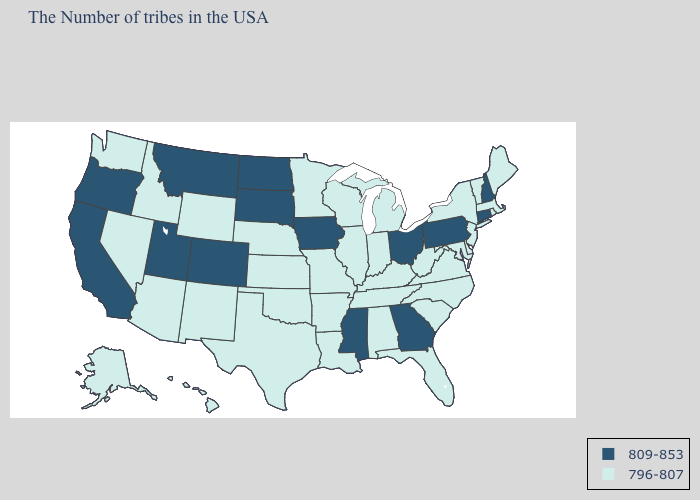Does Virginia have the highest value in the South?
Short answer required. No. Among the states that border North Carolina , which have the lowest value?
Write a very short answer. Virginia, South Carolina, Tennessee. What is the value of Arkansas?
Short answer required. 796-807. Does Tennessee have a lower value than Illinois?
Be succinct. No. Which states have the lowest value in the USA?
Write a very short answer. Maine, Massachusetts, Rhode Island, Vermont, New York, New Jersey, Delaware, Maryland, Virginia, North Carolina, South Carolina, West Virginia, Florida, Michigan, Kentucky, Indiana, Alabama, Tennessee, Wisconsin, Illinois, Louisiana, Missouri, Arkansas, Minnesota, Kansas, Nebraska, Oklahoma, Texas, Wyoming, New Mexico, Arizona, Idaho, Nevada, Washington, Alaska, Hawaii. How many symbols are there in the legend?
Quick response, please. 2. Which states have the lowest value in the USA?
Give a very brief answer. Maine, Massachusetts, Rhode Island, Vermont, New York, New Jersey, Delaware, Maryland, Virginia, North Carolina, South Carolina, West Virginia, Florida, Michigan, Kentucky, Indiana, Alabama, Tennessee, Wisconsin, Illinois, Louisiana, Missouri, Arkansas, Minnesota, Kansas, Nebraska, Oklahoma, Texas, Wyoming, New Mexico, Arizona, Idaho, Nevada, Washington, Alaska, Hawaii. What is the value of Mississippi?
Quick response, please. 809-853. What is the lowest value in the MidWest?
Short answer required. 796-807. Does the first symbol in the legend represent the smallest category?
Keep it brief. No. Name the states that have a value in the range 809-853?
Quick response, please. New Hampshire, Connecticut, Pennsylvania, Ohio, Georgia, Mississippi, Iowa, South Dakota, North Dakota, Colorado, Utah, Montana, California, Oregon. Which states have the lowest value in the South?
Keep it brief. Delaware, Maryland, Virginia, North Carolina, South Carolina, West Virginia, Florida, Kentucky, Alabama, Tennessee, Louisiana, Arkansas, Oklahoma, Texas. What is the value of Indiana?
Give a very brief answer. 796-807. Does Arkansas have the same value as New Hampshire?
Write a very short answer. No. Name the states that have a value in the range 809-853?
Be succinct. New Hampshire, Connecticut, Pennsylvania, Ohio, Georgia, Mississippi, Iowa, South Dakota, North Dakota, Colorado, Utah, Montana, California, Oregon. 